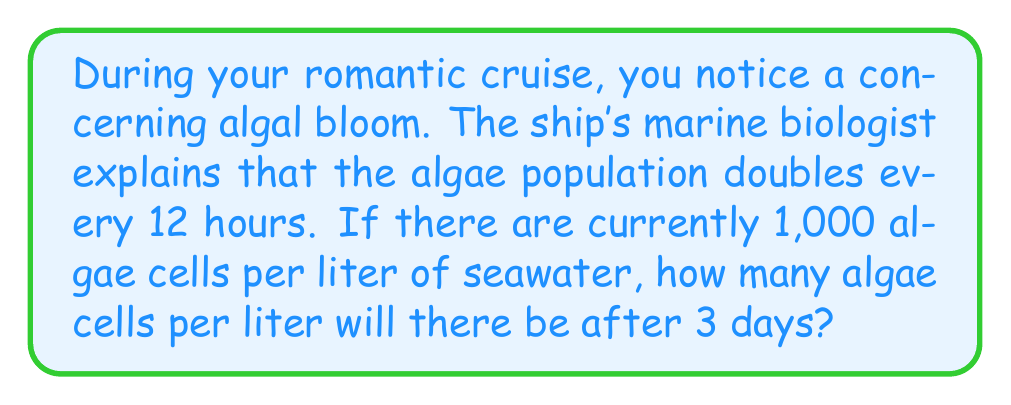Show me your answer to this math problem. Let's approach this step-by-step:

1) First, we need to determine how many 12-hour periods are in 3 days:
   $$ 3 \text{ days} = 3 \times 24 \text{ hours} = 72 \text{ hours} $$
   $$ 72 \text{ hours} \div 12 \text{ hours} = 6 \text{ periods} $$

2) Now, we know that the algae population doubles every period. This is an exponential growth pattern. We can express this mathematically as:

   $$ \text{Final Population} = \text{Initial Population} \times 2^{\text{number of periods}} $$

3) Let's plug in our values:
   - Initial Population: 1,000 cells per liter
   - Number of periods: 6

   $$ \text{Final Population} = 1,000 \times 2^6 $$

4) Now, let's calculate $2^6$:
   $$ 2^6 = 2 \times 2 \times 2 \times 2 \times 2 \times 2 = 64 $$

5) Finally, we multiply:
   $$ \text{Final Population} = 1,000 \times 64 = 64,000 \text{ cells per liter} $$

Therefore, after 3 days, there will be 64,000 algae cells per liter of seawater.
Answer: 64,000 cells per liter 